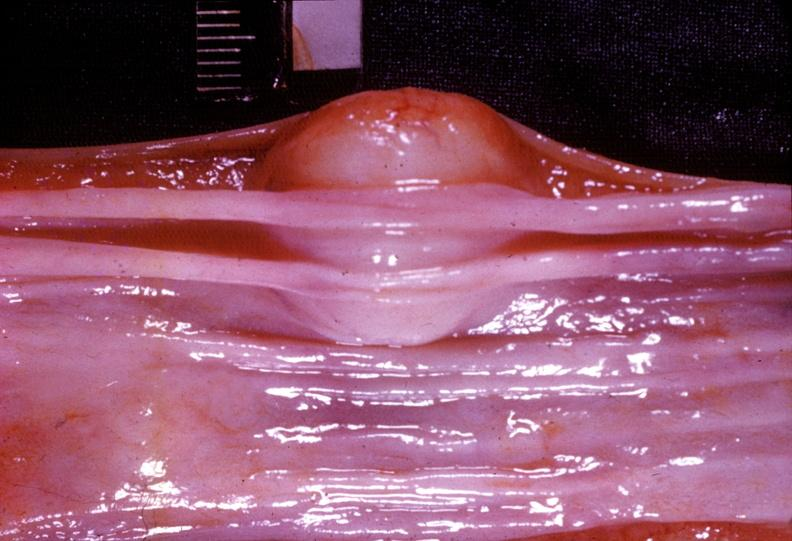does this image show esophagus, leiomyoma?
Answer the question using a single word or phrase. Yes 